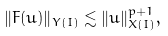<formula> <loc_0><loc_0><loc_500><loc_500>\| F ( u ) \| _ { Y ( I ) } \lesssim \| u \| _ { X ( I ) } ^ { p + 1 } ,</formula> 